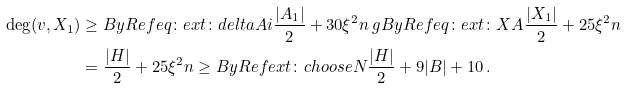Convert formula to latex. <formula><loc_0><loc_0><loc_500><loc_500>\deg ( v , X _ { 1 } ) & \geq B y R e f { e q \colon e x t \colon d e l t a A i } \frac { | A _ { 1 } | } { 2 } + 3 0 \xi ^ { 2 } n \ g B y R e f { e q \colon e x t \colon X A } \frac { | X _ { 1 } | } { 2 } + 2 5 \xi ^ { 2 } n \\ & = \frac { | H | } { 2 } + 2 5 \xi ^ { 2 } n \geq B y R e f { e x t \colon c h o o s e N } \frac { | H | } { 2 } + 9 | B | + 1 0 \, .</formula> 